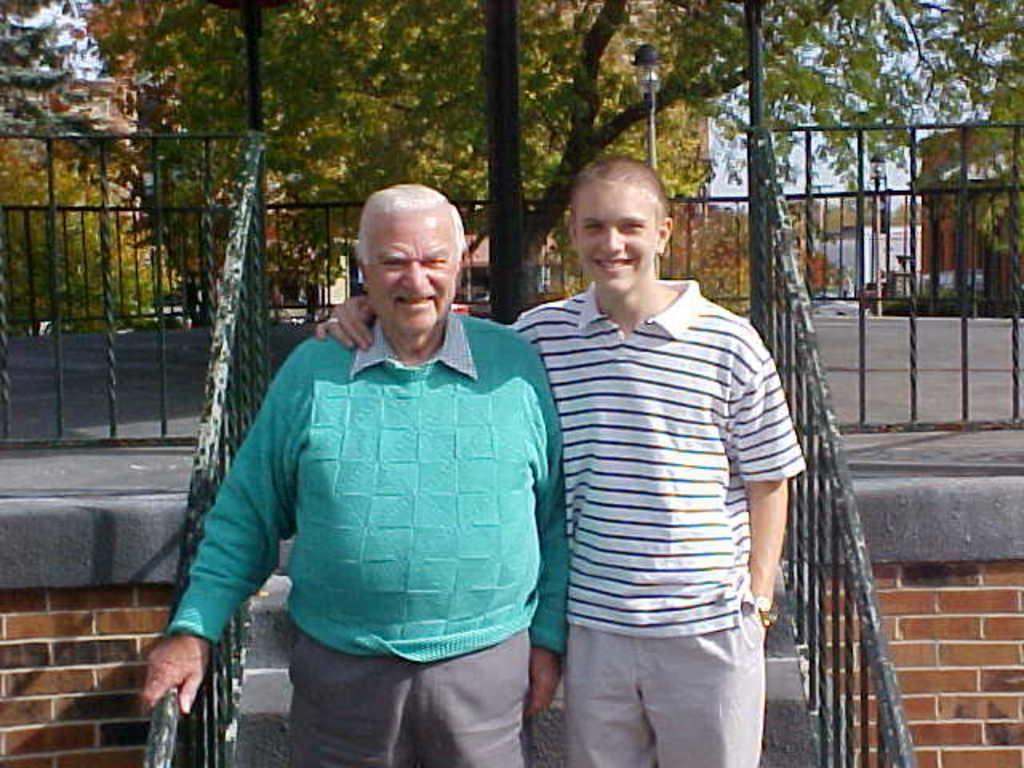Describe this image in one or two sentences. In this picture we can see two people standing and smiling. There is some fencing from left to right. We can see a few trees and buildings in the background. 